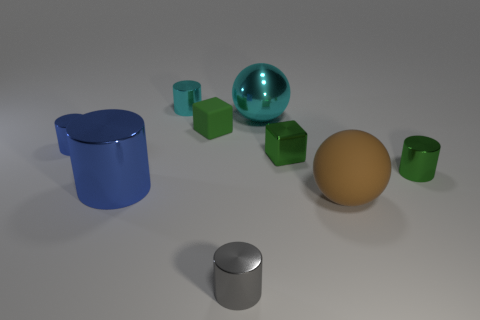What material are the objects made of, and how can you tell? The objects appear to be computer-generated and are designed to mimic different materials. The shiny, reflective sphere and cube suggest metallic properties, while the dull-colored objects could represent matte plastic or ceramic. The glossy finish on some items implies a polished, possibly metallic surface, and the lack of reflection on the matte objects suggests a non-metallic, absorbent material. Is there any pattern to the arrangement of objects? There isn't a discernible pattern in the arrangement of the objects. They are scattered randomly across the plane. Some are isolated, like the blue mug and the large gold sphere, and others are grouped, like the green cubes. Their placement does not suggest any intentional patterning. 